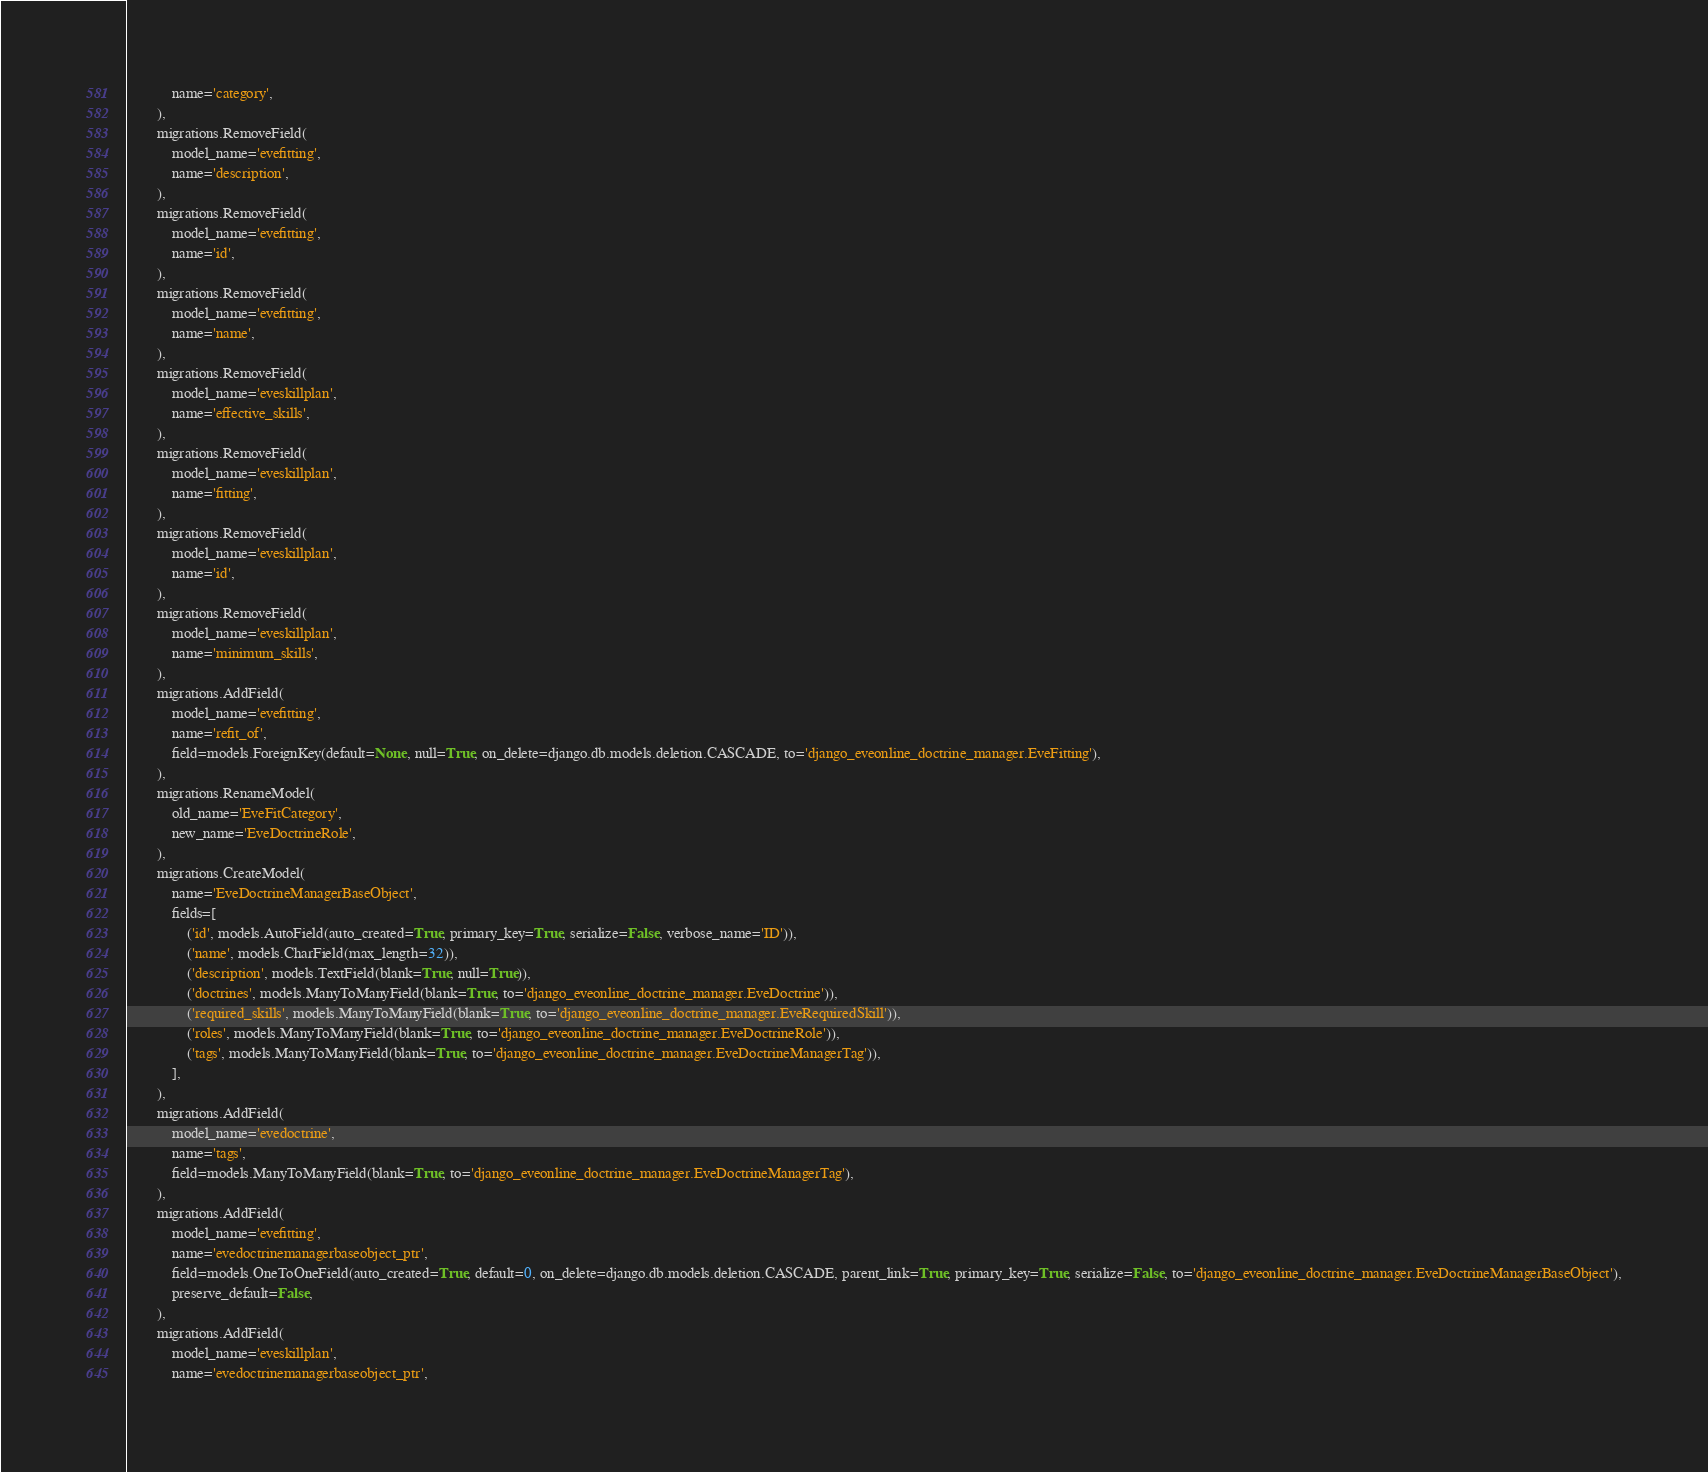Convert code to text. <code><loc_0><loc_0><loc_500><loc_500><_Python_>            name='category',
        ),
        migrations.RemoveField(
            model_name='evefitting',
            name='description',
        ),
        migrations.RemoveField(
            model_name='evefitting',
            name='id',
        ),
        migrations.RemoveField(
            model_name='evefitting',
            name='name',
        ),
        migrations.RemoveField(
            model_name='eveskillplan',
            name='effective_skills',
        ),
        migrations.RemoveField(
            model_name='eveskillplan',
            name='fitting',
        ),
        migrations.RemoveField(
            model_name='eveskillplan',
            name='id',
        ),
        migrations.RemoveField(
            model_name='eveskillplan',
            name='minimum_skills',
        ),
        migrations.AddField(
            model_name='evefitting',
            name='refit_of',
            field=models.ForeignKey(default=None, null=True, on_delete=django.db.models.deletion.CASCADE, to='django_eveonline_doctrine_manager.EveFitting'),
        ),
        migrations.RenameModel(
            old_name='EveFitCategory',
            new_name='EveDoctrineRole',
        ),
        migrations.CreateModel(
            name='EveDoctrineManagerBaseObject',
            fields=[
                ('id', models.AutoField(auto_created=True, primary_key=True, serialize=False, verbose_name='ID')),
                ('name', models.CharField(max_length=32)),
                ('description', models.TextField(blank=True, null=True)),
                ('doctrines', models.ManyToManyField(blank=True, to='django_eveonline_doctrine_manager.EveDoctrine')),
                ('required_skills', models.ManyToManyField(blank=True, to='django_eveonline_doctrine_manager.EveRequiredSkill')),
                ('roles', models.ManyToManyField(blank=True, to='django_eveonline_doctrine_manager.EveDoctrineRole')),
                ('tags', models.ManyToManyField(blank=True, to='django_eveonline_doctrine_manager.EveDoctrineManagerTag')),
            ],
        ),
        migrations.AddField(
            model_name='evedoctrine',
            name='tags',
            field=models.ManyToManyField(blank=True, to='django_eveonline_doctrine_manager.EveDoctrineManagerTag'),
        ),
        migrations.AddField(
            model_name='evefitting',
            name='evedoctrinemanagerbaseobject_ptr',
            field=models.OneToOneField(auto_created=True, default=0, on_delete=django.db.models.deletion.CASCADE, parent_link=True, primary_key=True, serialize=False, to='django_eveonline_doctrine_manager.EveDoctrineManagerBaseObject'),
            preserve_default=False,
        ),
        migrations.AddField(
            model_name='eveskillplan',
            name='evedoctrinemanagerbaseobject_ptr',</code> 